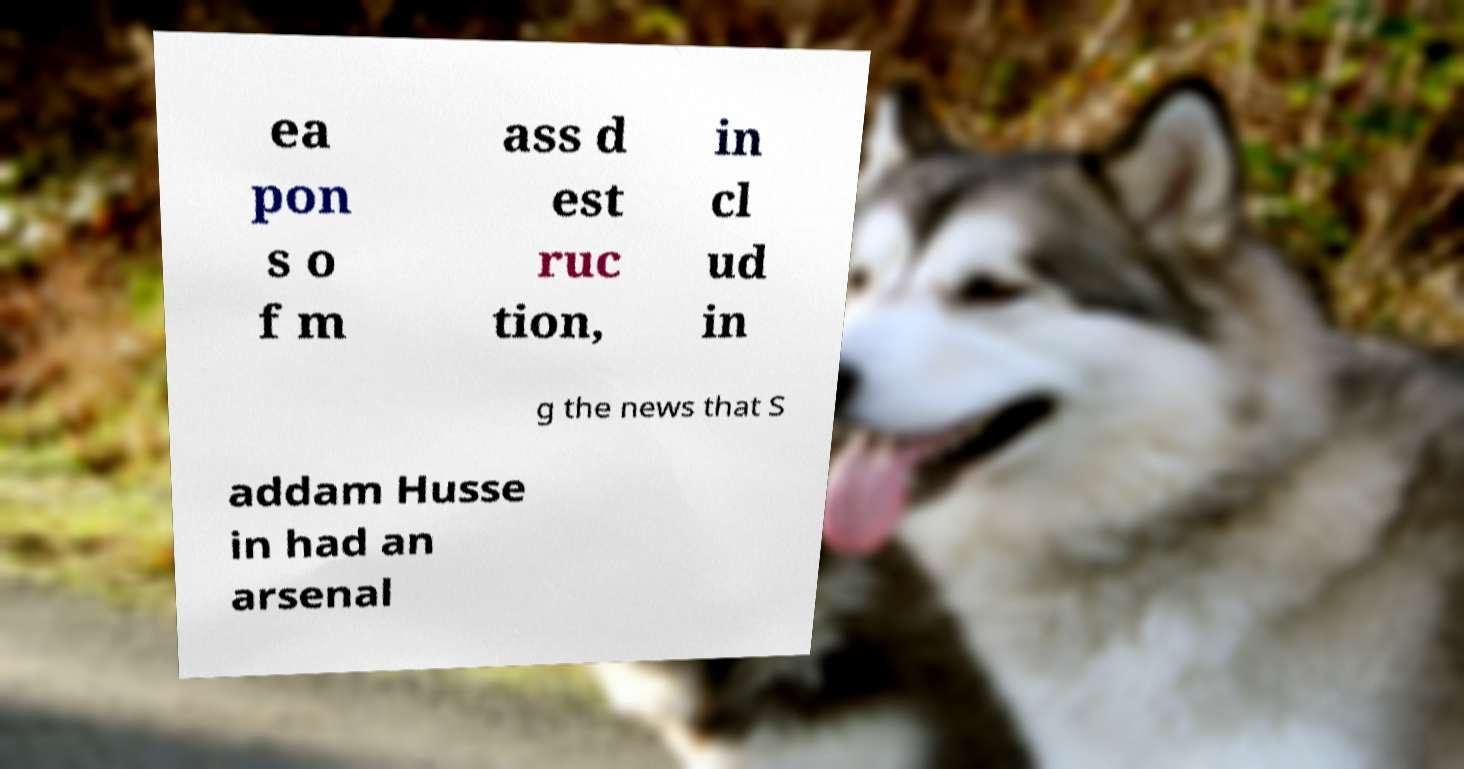Please read and relay the text visible in this image. What does it say? ea pon s o f m ass d est ruc tion, in cl ud in g the news that S addam Husse in had an arsenal 